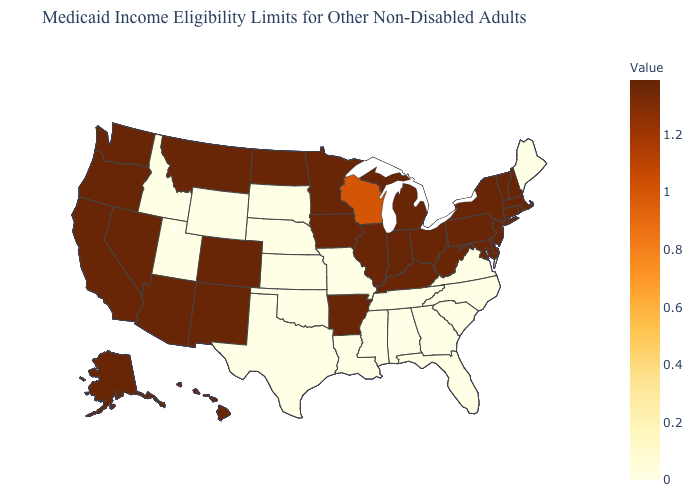Does Idaho have the lowest value in the USA?
Write a very short answer. Yes. Which states have the highest value in the USA?
Answer briefly. Indiana. Which states have the highest value in the USA?
Keep it brief. Indiana. Does Maryland have the highest value in the South?
Write a very short answer. Yes. 